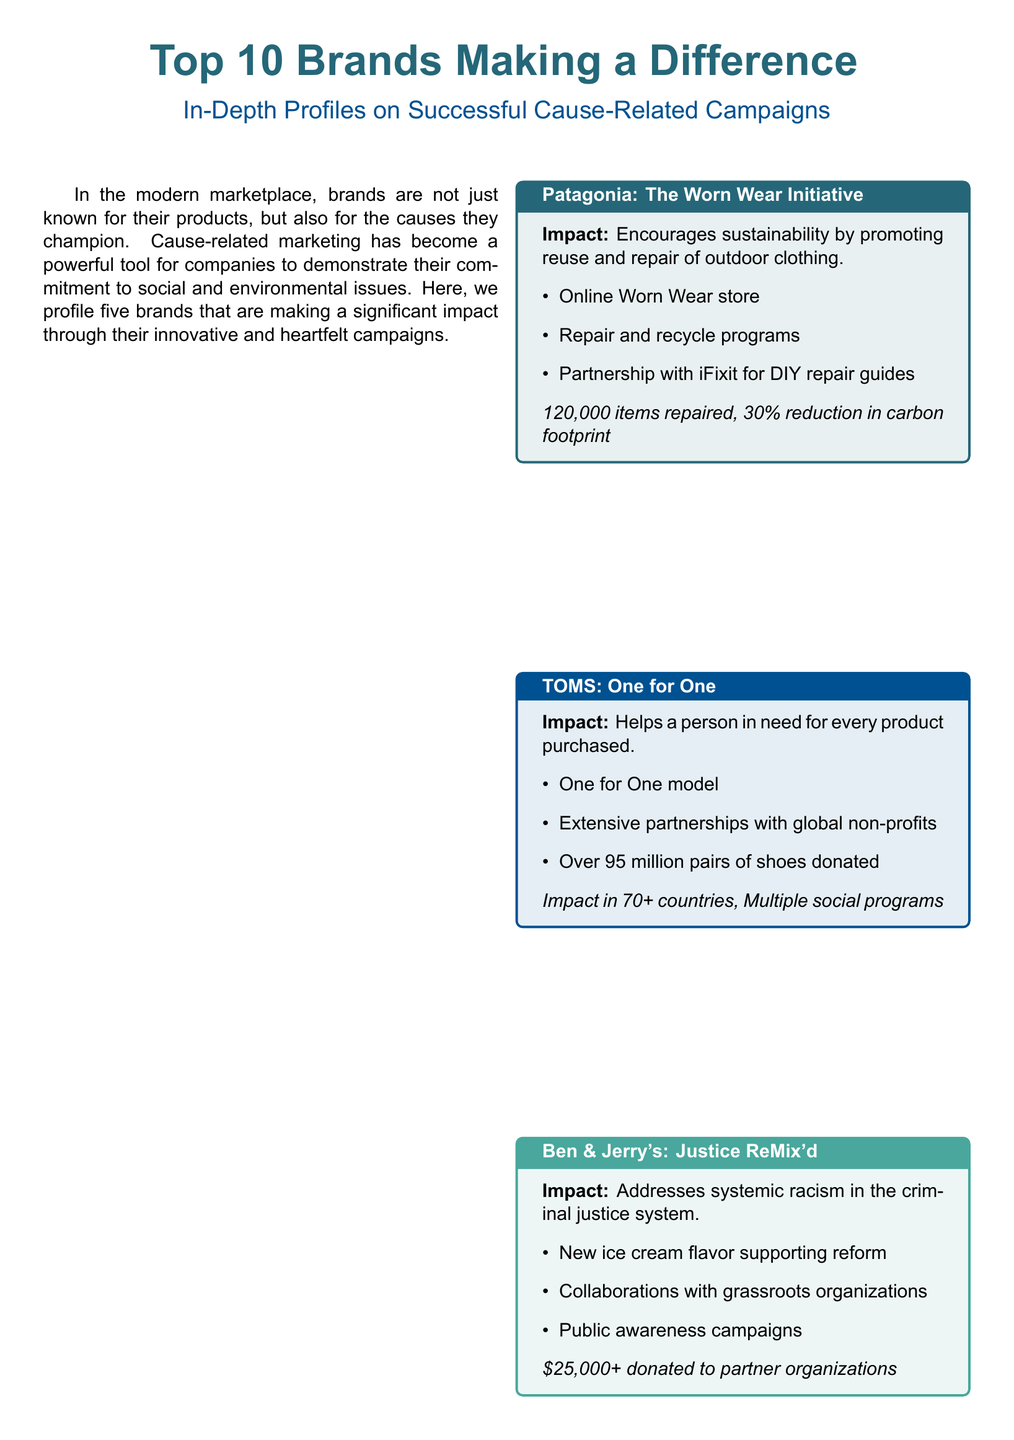What is the title of the initiative by Patagonia? The title of the initiative by Patagonia is stated as "The Worn Wear Initiative."
Answer: The Worn Wear Initiative How many items has Patagonia repaired? The document highlights that Patagonia has repaired 120,000 items.
Answer: 120,000 items What model does TOMS operate under? The document indicates that TOMS operates under the "One for One" model.
Answer: One for One How much money did Ben & Jerry's donate to partner organizations? The document mentions that Ben & Jerry's donated over $25,000 to partner organizations.
Answer: $25,000+ What is the impact of Nike's campaign? Nike's campaign promotes gender equality in sports.
Answer: Gender equality in sports How many educational kits has LEGO distributed? According to the document, LEGO distributed 1 million educational kits.
Answer: 1 million What was the growth percentage in women's sportswear sales for Nike? The document states that there was a 20% growth in women's sportswear sales.
Answer: 20% What type of programs does LEGO partner with? LEGO partners with educational programs as noted in the document.
Answer: Educational programs How does cause-related marketing affect company image? The document concludes that cause-related marketing enhances a company's image.
Answer: Enhances a company's image What is essential for the success of these brands' campaigns? According to the conclusion, authentic commitment is key for success.
Answer: Authentic commitment 